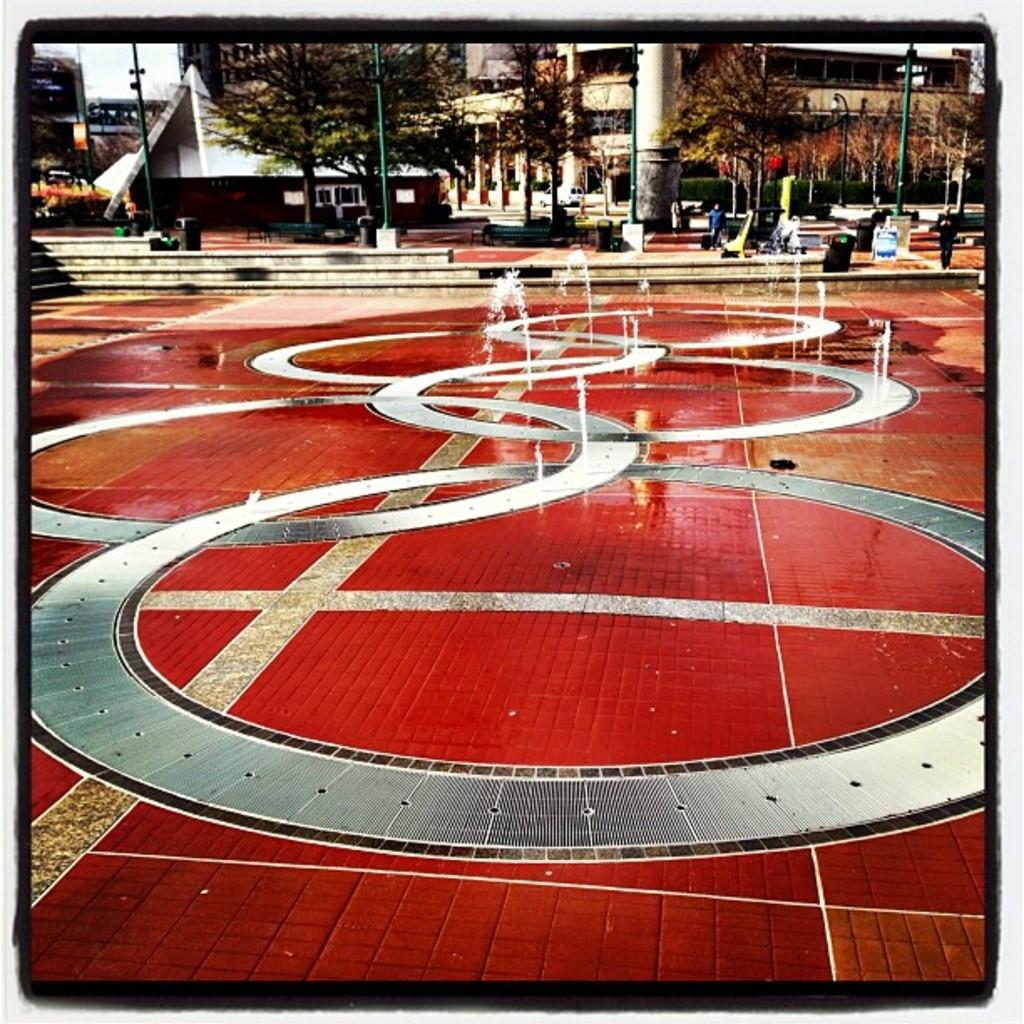What is visible in the image? Water, buildings, trees, people, poles, and the sky are visible in the background of the image. There is also a design on the floor of the image. Can you describe the design on the floor? The design on the floor is not specified in the facts provided. What type of structures can be seen in the background of the image? Buildings can be seen in the background of the image. What else is present in the background of the image? Trees, people, poles, and the sky are also present in the background of the image. Where is the faucet located in the image? There is no faucet present in the image. Is there a volcano visible in the image? There is no volcano present in the image. 